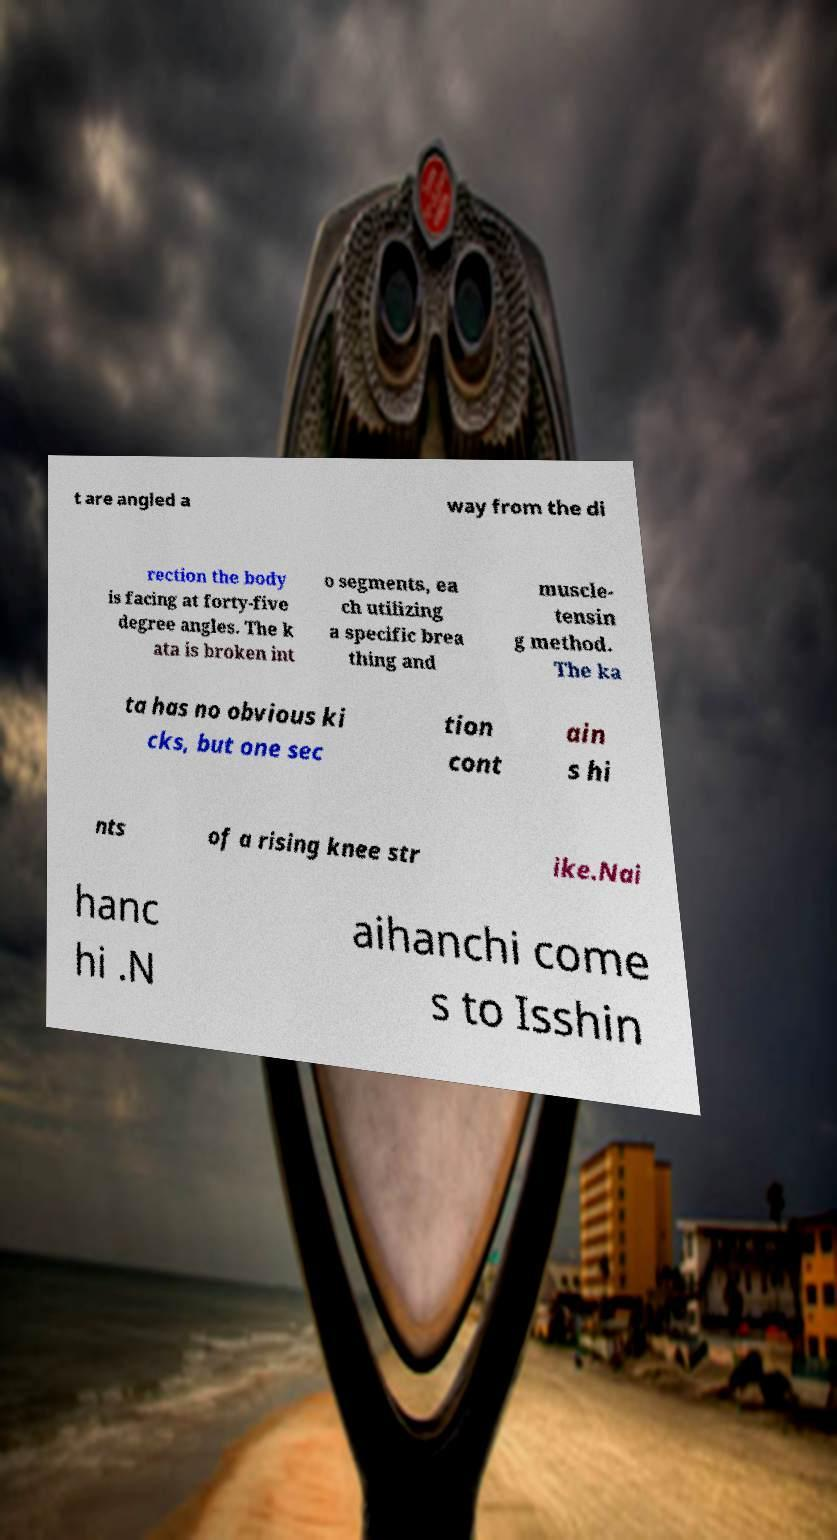Can you read and provide the text displayed in the image?This photo seems to have some interesting text. Can you extract and type it out for me? t are angled a way from the di rection the body is facing at forty-five degree angles. The k ata is broken int o segments, ea ch utilizing a specific brea thing and muscle- tensin g method. The ka ta has no obvious ki cks, but one sec tion cont ain s hi nts of a rising knee str ike.Nai hanc hi .N aihanchi come s to Isshin 